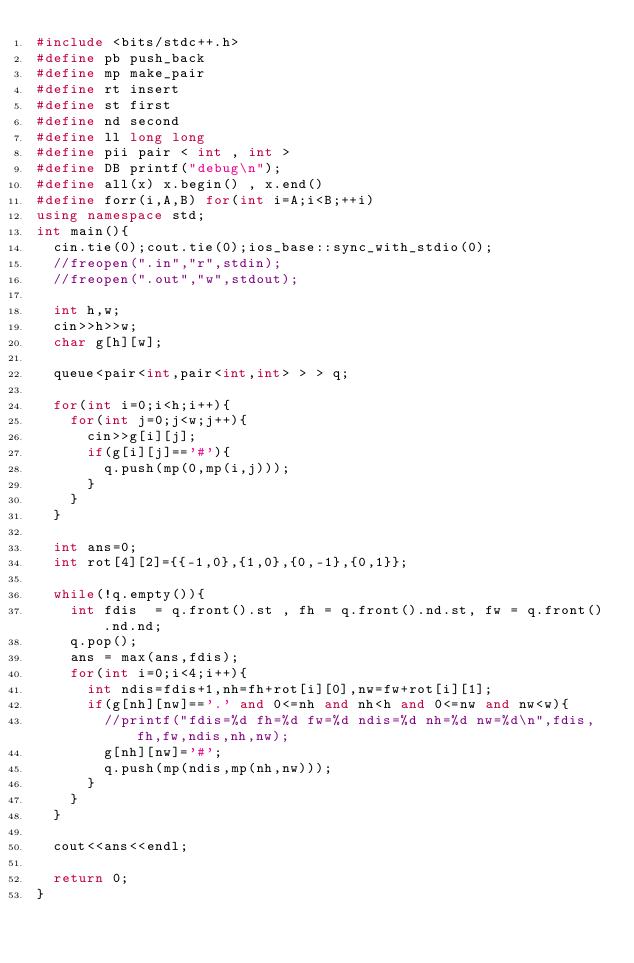Convert code to text. <code><loc_0><loc_0><loc_500><loc_500><_C++_>#include <bits/stdc++.h>
#define pb push_back
#define mp make_pair
#define rt insert
#define st first
#define nd second
#define ll long long
#define pii pair < int , int >
#define DB printf("debug\n");
#define all(x) x.begin() , x.end()
#define forr(i,A,B) for(int i=A;i<B;++i)
using namespace std;
int main(){
	cin.tie(0);cout.tie(0);ios_base::sync_with_stdio(0);
	//freopen(".in","r",stdin);
	//freopen(".out","w",stdout);

	int h,w;
	cin>>h>>w;
	char g[h][w];

	queue<pair<int,pair<int,int> > > q;

	for(int i=0;i<h;i++){
		for(int j=0;j<w;j++){
			cin>>g[i][j];
			if(g[i][j]=='#'){
				q.push(mp(0,mp(i,j)));
			}
		}
	}

	int ans=0;
	int rot[4][2]={{-1,0},{1,0},{0,-1},{0,1}};

	while(!q.empty()){
		int fdis  = q.front().st , fh = q.front().nd.st, fw = q.front().nd.nd;
		q.pop();
		ans = max(ans,fdis);
		for(int i=0;i<4;i++){
			int ndis=fdis+1,nh=fh+rot[i][0],nw=fw+rot[i][1];
			if(g[nh][nw]=='.' and 0<=nh and nh<h and 0<=nw and nw<w){
				//printf("fdis=%d fh=%d fw=%d ndis=%d nh=%d nw=%d\n",fdis,fh,fw,ndis,nh,nw);
				g[nh][nw]='#';
				q.push(mp(ndis,mp(nh,nw)));
			}
		}
	}

	cout<<ans<<endl;
	
	return 0;
}</code> 